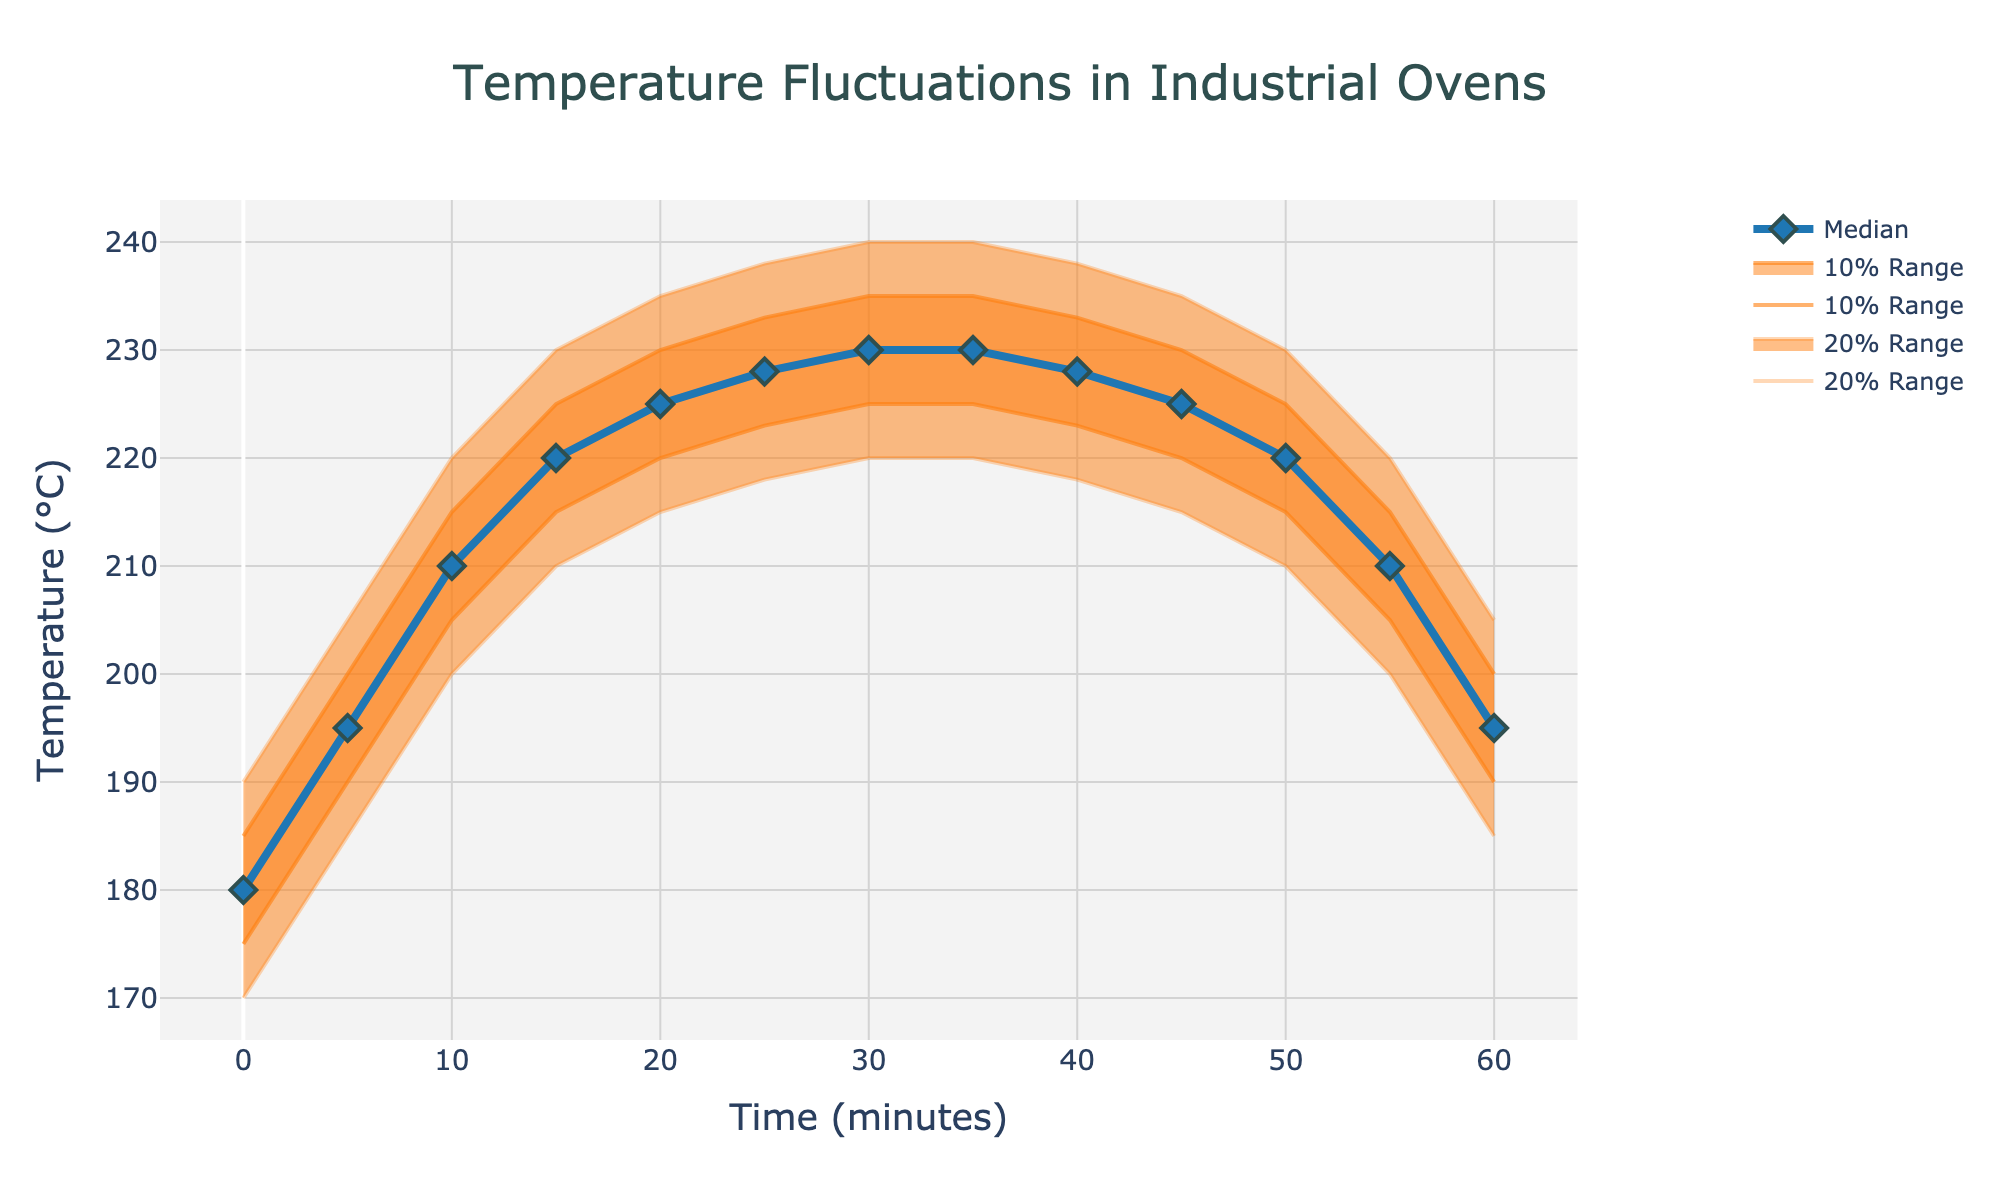What is the title of the figure? The title is prominently displayed at the top of the figure.
Answer: Temperature Fluctuations in Industrial Ovens What is the median temperature at time 30 minutes? The median temperature is represented by the blue line and marked with diamond symbols. At 30 minutes, follow this line to the y-axis.
Answer: 230°C What are the highest and lowest temperatures recorded at time 10 minutes within the 20% range? The 20% range is represented by the light orange shaded area. Read the highest and lowest points within this area at 10 minutes.
Answer: Highest: 220°C, Lowest: 200°C How does the temperature trend change from 0 to 60 minutes? Observe the median temperature line from the start to the end. Notice the general upward and then a downward trend.
Answer: Initially increases, then decreases At which time point is the median temperature the highest? Look for the peak of the blue line representing the median temperature across all time points.
Answer: 35 minutes Compare the temperature variability at 5 and 50 minutes. Which one shows a wider range within the 20% band? To compare, check the light orange shaded areas at 5 and 50 minutes. Measure the spread between the top and bottom lines.
Answer: 5 minutes What is the difference between the median temperature and the highest temperature within the 20% range at 25 minutes? The median temperature at 25 minutes is 228°C. The highest within the 20% range is 238°C. Subtract the median from this highest value.
Answer: 10°C By how many degrees does the median temperature increase from 0 to 20 minutes? The median temperature at 0 minutes is 180°C, and at 20 minutes, it is 225°C. Find the difference between these two values.
Answer: 45°C Between 30 and 35 minutes, does the median temperature increase, decrease, or remain the same? Compare the median temperature values at 30 and 35 minutes.
Answer: Remains the same Which color is used to represent the 10% variance range and how does it differ from the 20% variance range? The 10% range is shown in a darker shade of orange while the 20% range is in a lighter shade of orange.
Answer: Darker orange for 10%, lighter orange for 20% 